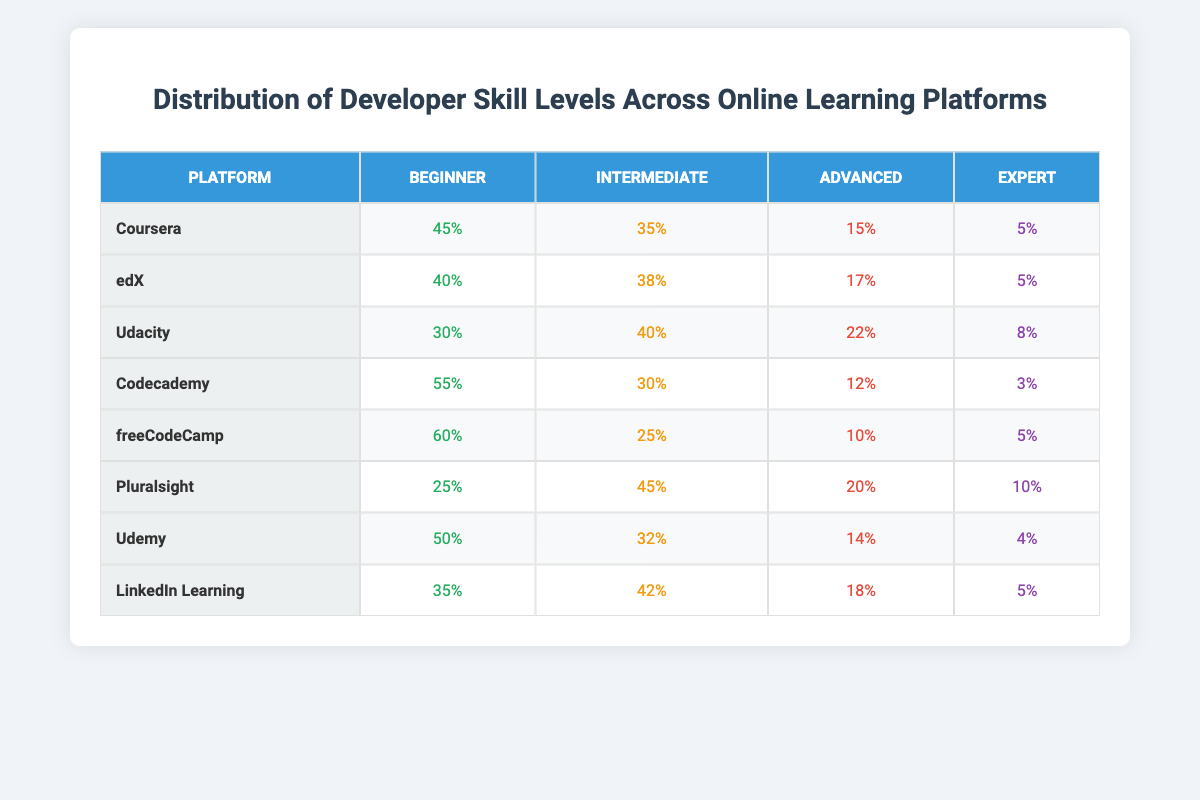What is the percentage of beginners on Coursera? According to the table, Coursera has a beginner percentage of 45%.
Answer: 45% Which platform has the highest percentage of intermediate learners? By examining the table, Pluralsight has the highest percentage of intermediate learners at 45%.
Answer: Pluralsight What is the total percentage of experts across all platforms? Adding the expert percentages: 5 + 5 + 8 + 3 + 5 + 10 + 4 + 5 equals 45%.
Answer: 45% What is the difference in the percentage of advanced learners between Codecademy and Udacity? Codecademy has 12% advanced learners, while Udacity has 22%. The difference is 22 - 12 = 10%.
Answer: 10% Which platform has the lowest total skill level percentage when summed up? By adding the percentages of each skill level for all platforms, Codecademy has the lowest total (30 + 12 + 3 + 55 = 100).
Answer: Codecademy Is there a platform with no advanced learners? Inspecting the table, Codecademy has only 12% advanced learners, while others have higher percentages, meaning yes, Codecademy has the lowest.
Answer: Yes What is the average percentage of beginners across all platforms? Calculating the average for beginners: (45 + 40 + 30 + 55 + 60 + 25 + 50 + 35) / 8 = 43.125%, rounded to 43%.
Answer: 43% Which platforms have similar distributions of expert learners? By looking for similar expert percentages in the table, Coursera (5%) and edX (5%) have the same expert learner percentage.
Answer: Coursera and edX Which platform has the highest total of all skill levels combined? All platforms have a total of 100% across skill levels, so every platform has an equal total. Therefore, no platform stands out in this regard.
Answer: All platforms are equal What is the percentage of advanced learners in the platform with the least percentage of beginners? FreeCodeCamp has the least percentage of beginners at 60%, while the advanced percentage is 10%. Therefore, the percentage of advanced learners is 10%.
Answer: 10% 